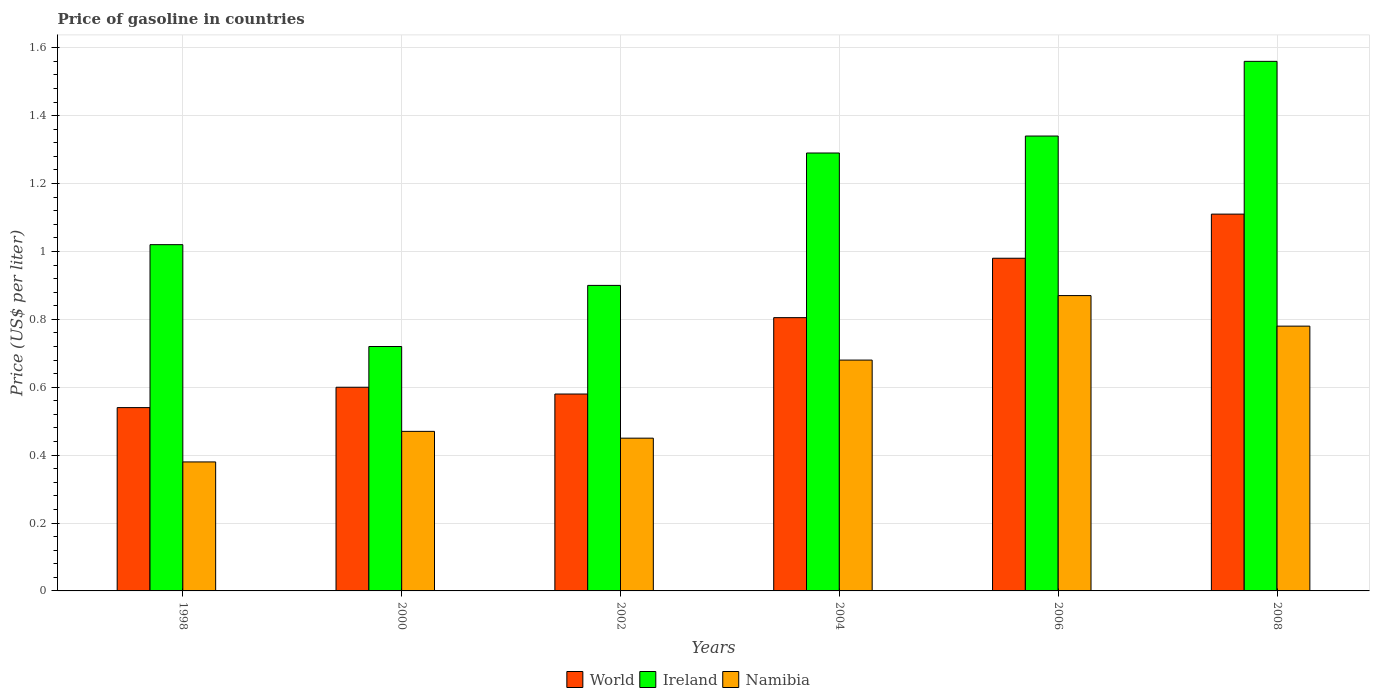Are the number of bars per tick equal to the number of legend labels?
Your answer should be very brief. Yes. How many bars are there on the 4th tick from the left?
Keep it short and to the point. 3. How many bars are there on the 5th tick from the right?
Your answer should be very brief. 3. In how many cases, is the number of bars for a given year not equal to the number of legend labels?
Offer a terse response. 0. What is the price of gasoline in Namibia in 2008?
Provide a short and direct response. 0.78. Across all years, what is the maximum price of gasoline in Ireland?
Make the answer very short. 1.56. Across all years, what is the minimum price of gasoline in Namibia?
Ensure brevity in your answer.  0.38. What is the total price of gasoline in Ireland in the graph?
Give a very brief answer. 6.83. What is the difference between the price of gasoline in Namibia in 1998 and that in 2000?
Keep it short and to the point. -0.09. What is the difference between the price of gasoline in Namibia in 2002 and the price of gasoline in Ireland in 2004?
Offer a terse response. -0.84. What is the average price of gasoline in World per year?
Your answer should be compact. 0.77. In the year 2008, what is the difference between the price of gasoline in Namibia and price of gasoline in Ireland?
Make the answer very short. -0.78. In how many years, is the price of gasoline in Ireland greater than 1.12 US$?
Provide a succinct answer. 3. What is the ratio of the price of gasoline in World in 1998 to that in 2008?
Provide a succinct answer. 0.49. Is the difference between the price of gasoline in Namibia in 2000 and 2002 greater than the difference between the price of gasoline in Ireland in 2000 and 2002?
Your answer should be very brief. Yes. What is the difference between the highest and the second highest price of gasoline in World?
Give a very brief answer. 0.13. What is the difference between the highest and the lowest price of gasoline in Ireland?
Provide a succinct answer. 0.84. What does the 2nd bar from the left in 2004 represents?
Your answer should be compact. Ireland. What does the 1st bar from the right in 2000 represents?
Give a very brief answer. Namibia. How many bars are there?
Provide a short and direct response. 18. Are all the bars in the graph horizontal?
Provide a short and direct response. No. What is the difference between two consecutive major ticks on the Y-axis?
Keep it short and to the point. 0.2. Are the values on the major ticks of Y-axis written in scientific E-notation?
Provide a short and direct response. No. Does the graph contain any zero values?
Your answer should be compact. No. Does the graph contain grids?
Offer a very short reply. Yes. Where does the legend appear in the graph?
Offer a terse response. Bottom center. How are the legend labels stacked?
Your answer should be very brief. Horizontal. What is the title of the graph?
Offer a very short reply. Price of gasoline in countries. What is the label or title of the X-axis?
Your response must be concise. Years. What is the label or title of the Y-axis?
Make the answer very short. Price (US$ per liter). What is the Price (US$ per liter) in World in 1998?
Ensure brevity in your answer.  0.54. What is the Price (US$ per liter) in Namibia in 1998?
Your answer should be very brief. 0.38. What is the Price (US$ per liter) in World in 2000?
Your answer should be compact. 0.6. What is the Price (US$ per liter) in Ireland in 2000?
Offer a terse response. 0.72. What is the Price (US$ per liter) in Namibia in 2000?
Provide a succinct answer. 0.47. What is the Price (US$ per liter) in World in 2002?
Give a very brief answer. 0.58. What is the Price (US$ per liter) in Namibia in 2002?
Keep it short and to the point. 0.45. What is the Price (US$ per liter) in World in 2004?
Your answer should be very brief. 0.81. What is the Price (US$ per liter) of Ireland in 2004?
Keep it short and to the point. 1.29. What is the Price (US$ per liter) of Namibia in 2004?
Offer a terse response. 0.68. What is the Price (US$ per liter) in Ireland in 2006?
Give a very brief answer. 1.34. What is the Price (US$ per liter) in Namibia in 2006?
Your response must be concise. 0.87. What is the Price (US$ per liter) in World in 2008?
Offer a very short reply. 1.11. What is the Price (US$ per liter) of Ireland in 2008?
Your response must be concise. 1.56. What is the Price (US$ per liter) of Namibia in 2008?
Offer a terse response. 0.78. Across all years, what is the maximum Price (US$ per liter) of World?
Give a very brief answer. 1.11. Across all years, what is the maximum Price (US$ per liter) in Ireland?
Your answer should be very brief. 1.56. Across all years, what is the maximum Price (US$ per liter) in Namibia?
Ensure brevity in your answer.  0.87. Across all years, what is the minimum Price (US$ per liter) of World?
Provide a succinct answer. 0.54. Across all years, what is the minimum Price (US$ per liter) of Ireland?
Your answer should be compact. 0.72. Across all years, what is the minimum Price (US$ per liter) in Namibia?
Offer a very short reply. 0.38. What is the total Price (US$ per liter) in World in the graph?
Your response must be concise. 4.62. What is the total Price (US$ per liter) in Ireland in the graph?
Keep it short and to the point. 6.83. What is the total Price (US$ per liter) of Namibia in the graph?
Keep it short and to the point. 3.63. What is the difference between the Price (US$ per liter) of World in 1998 and that in 2000?
Make the answer very short. -0.06. What is the difference between the Price (US$ per liter) in Ireland in 1998 and that in 2000?
Offer a very short reply. 0.3. What is the difference between the Price (US$ per liter) of Namibia in 1998 and that in 2000?
Offer a very short reply. -0.09. What is the difference between the Price (US$ per liter) of World in 1998 and that in 2002?
Your answer should be very brief. -0.04. What is the difference between the Price (US$ per liter) of Ireland in 1998 and that in 2002?
Make the answer very short. 0.12. What is the difference between the Price (US$ per liter) of Namibia in 1998 and that in 2002?
Your answer should be very brief. -0.07. What is the difference between the Price (US$ per liter) in World in 1998 and that in 2004?
Your answer should be compact. -0.27. What is the difference between the Price (US$ per liter) in Ireland in 1998 and that in 2004?
Your answer should be compact. -0.27. What is the difference between the Price (US$ per liter) of Namibia in 1998 and that in 2004?
Offer a very short reply. -0.3. What is the difference between the Price (US$ per liter) in World in 1998 and that in 2006?
Give a very brief answer. -0.44. What is the difference between the Price (US$ per liter) of Ireland in 1998 and that in 2006?
Offer a terse response. -0.32. What is the difference between the Price (US$ per liter) in Namibia in 1998 and that in 2006?
Offer a very short reply. -0.49. What is the difference between the Price (US$ per liter) in World in 1998 and that in 2008?
Provide a short and direct response. -0.57. What is the difference between the Price (US$ per liter) of Ireland in 1998 and that in 2008?
Your answer should be very brief. -0.54. What is the difference between the Price (US$ per liter) of Namibia in 1998 and that in 2008?
Provide a succinct answer. -0.4. What is the difference between the Price (US$ per liter) of World in 2000 and that in 2002?
Keep it short and to the point. 0.02. What is the difference between the Price (US$ per liter) of Ireland in 2000 and that in 2002?
Give a very brief answer. -0.18. What is the difference between the Price (US$ per liter) in World in 2000 and that in 2004?
Keep it short and to the point. -0.2. What is the difference between the Price (US$ per liter) in Ireland in 2000 and that in 2004?
Your response must be concise. -0.57. What is the difference between the Price (US$ per liter) of Namibia in 2000 and that in 2004?
Give a very brief answer. -0.21. What is the difference between the Price (US$ per liter) of World in 2000 and that in 2006?
Ensure brevity in your answer.  -0.38. What is the difference between the Price (US$ per liter) in Ireland in 2000 and that in 2006?
Provide a short and direct response. -0.62. What is the difference between the Price (US$ per liter) of Namibia in 2000 and that in 2006?
Offer a very short reply. -0.4. What is the difference between the Price (US$ per liter) in World in 2000 and that in 2008?
Ensure brevity in your answer.  -0.51. What is the difference between the Price (US$ per liter) of Ireland in 2000 and that in 2008?
Your response must be concise. -0.84. What is the difference between the Price (US$ per liter) of Namibia in 2000 and that in 2008?
Provide a succinct answer. -0.31. What is the difference between the Price (US$ per liter) in World in 2002 and that in 2004?
Make the answer very short. -0.23. What is the difference between the Price (US$ per liter) in Ireland in 2002 and that in 2004?
Give a very brief answer. -0.39. What is the difference between the Price (US$ per liter) in Namibia in 2002 and that in 2004?
Your answer should be compact. -0.23. What is the difference between the Price (US$ per liter) in Ireland in 2002 and that in 2006?
Offer a terse response. -0.44. What is the difference between the Price (US$ per liter) in Namibia in 2002 and that in 2006?
Your answer should be compact. -0.42. What is the difference between the Price (US$ per liter) of World in 2002 and that in 2008?
Make the answer very short. -0.53. What is the difference between the Price (US$ per liter) in Ireland in 2002 and that in 2008?
Make the answer very short. -0.66. What is the difference between the Price (US$ per liter) in Namibia in 2002 and that in 2008?
Provide a succinct answer. -0.33. What is the difference between the Price (US$ per liter) in World in 2004 and that in 2006?
Provide a succinct answer. -0.17. What is the difference between the Price (US$ per liter) of Namibia in 2004 and that in 2006?
Offer a terse response. -0.19. What is the difference between the Price (US$ per liter) of World in 2004 and that in 2008?
Offer a terse response. -0.3. What is the difference between the Price (US$ per liter) in Ireland in 2004 and that in 2008?
Offer a very short reply. -0.27. What is the difference between the Price (US$ per liter) of World in 2006 and that in 2008?
Your answer should be compact. -0.13. What is the difference between the Price (US$ per liter) in Ireland in 2006 and that in 2008?
Offer a very short reply. -0.22. What is the difference between the Price (US$ per liter) of Namibia in 2006 and that in 2008?
Give a very brief answer. 0.09. What is the difference between the Price (US$ per liter) of World in 1998 and the Price (US$ per liter) of Ireland in 2000?
Give a very brief answer. -0.18. What is the difference between the Price (US$ per liter) of World in 1998 and the Price (US$ per liter) of Namibia in 2000?
Keep it short and to the point. 0.07. What is the difference between the Price (US$ per liter) of Ireland in 1998 and the Price (US$ per liter) of Namibia in 2000?
Ensure brevity in your answer.  0.55. What is the difference between the Price (US$ per liter) of World in 1998 and the Price (US$ per liter) of Ireland in 2002?
Ensure brevity in your answer.  -0.36. What is the difference between the Price (US$ per liter) in World in 1998 and the Price (US$ per liter) in Namibia in 2002?
Provide a succinct answer. 0.09. What is the difference between the Price (US$ per liter) in Ireland in 1998 and the Price (US$ per liter) in Namibia in 2002?
Your response must be concise. 0.57. What is the difference between the Price (US$ per liter) in World in 1998 and the Price (US$ per liter) in Ireland in 2004?
Keep it short and to the point. -0.75. What is the difference between the Price (US$ per liter) of World in 1998 and the Price (US$ per liter) of Namibia in 2004?
Ensure brevity in your answer.  -0.14. What is the difference between the Price (US$ per liter) of Ireland in 1998 and the Price (US$ per liter) of Namibia in 2004?
Your answer should be compact. 0.34. What is the difference between the Price (US$ per liter) in World in 1998 and the Price (US$ per liter) in Namibia in 2006?
Provide a succinct answer. -0.33. What is the difference between the Price (US$ per liter) in Ireland in 1998 and the Price (US$ per liter) in Namibia in 2006?
Your response must be concise. 0.15. What is the difference between the Price (US$ per liter) in World in 1998 and the Price (US$ per liter) in Ireland in 2008?
Make the answer very short. -1.02. What is the difference between the Price (US$ per liter) in World in 1998 and the Price (US$ per liter) in Namibia in 2008?
Keep it short and to the point. -0.24. What is the difference between the Price (US$ per liter) of Ireland in 1998 and the Price (US$ per liter) of Namibia in 2008?
Offer a terse response. 0.24. What is the difference between the Price (US$ per liter) of Ireland in 2000 and the Price (US$ per liter) of Namibia in 2002?
Give a very brief answer. 0.27. What is the difference between the Price (US$ per liter) of World in 2000 and the Price (US$ per liter) of Ireland in 2004?
Your answer should be very brief. -0.69. What is the difference between the Price (US$ per liter) of World in 2000 and the Price (US$ per liter) of Namibia in 2004?
Your answer should be compact. -0.08. What is the difference between the Price (US$ per liter) in Ireland in 2000 and the Price (US$ per liter) in Namibia in 2004?
Provide a short and direct response. 0.04. What is the difference between the Price (US$ per liter) in World in 2000 and the Price (US$ per liter) in Ireland in 2006?
Your answer should be very brief. -0.74. What is the difference between the Price (US$ per liter) of World in 2000 and the Price (US$ per liter) of Namibia in 2006?
Your answer should be very brief. -0.27. What is the difference between the Price (US$ per liter) of World in 2000 and the Price (US$ per liter) of Ireland in 2008?
Ensure brevity in your answer.  -0.96. What is the difference between the Price (US$ per liter) of World in 2000 and the Price (US$ per liter) of Namibia in 2008?
Ensure brevity in your answer.  -0.18. What is the difference between the Price (US$ per liter) of Ireland in 2000 and the Price (US$ per liter) of Namibia in 2008?
Ensure brevity in your answer.  -0.06. What is the difference between the Price (US$ per liter) in World in 2002 and the Price (US$ per liter) in Ireland in 2004?
Offer a terse response. -0.71. What is the difference between the Price (US$ per liter) of Ireland in 2002 and the Price (US$ per liter) of Namibia in 2004?
Offer a very short reply. 0.22. What is the difference between the Price (US$ per liter) of World in 2002 and the Price (US$ per liter) of Ireland in 2006?
Give a very brief answer. -0.76. What is the difference between the Price (US$ per liter) of World in 2002 and the Price (US$ per liter) of Namibia in 2006?
Provide a short and direct response. -0.29. What is the difference between the Price (US$ per liter) of Ireland in 2002 and the Price (US$ per liter) of Namibia in 2006?
Your answer should be compact. 0.03. What is the difference between the Price (US$ per liter) in World in 2002 and the Price (US$ per liter) in Ireland in 2008?
Your answer should be compact. -0.98. What is the difference between the Price (US$ per liter) of World in 2002 and the Price (US$ per liter) of Namibia in 2008?
Provide a succinct answer. -0.2. What is the difference between the Price (US$ per liter) in Ireland in 2002 and the Price (US$ per liter) in Namibia in 2008?
Make the answer very short. 0.12. What is the difference between the Price (US$ per liter) of World in 2004 and the Price (US$ per liter) of Ireland in 2006?
Provide a short and direct response. -0.54. What is the difference between the Price (US$ per liter) of World in 2004 and the Price (US$ per liter) of Namibia in 2006?
Offer a very short reply. -0.07. What is the difference between the Price (US$ per liter) of Ireland in 2004 and the Price (US$ per liter) of Namibia in 2006?
Your answer should be very brief. 0.42. What is the difference between the Price (US$ per liter) in World in 2004 and the Price (US$ per liter) in Ireland in 2008?
Keep it short and to the point. -0.76. What is the difference between the Price (US$ per liter) in World in 2004 and the Price (US$ per liter) in Namibia in 2008?
Your response must be concise. 0.03. What is the difference between the Price (US$ per liter) of Ireland in 2004 and the Price (US$ per liter) of Namibia in 2008?
Your answer should be compact. 0.51. What is the difference between the Price (US$ per liter) of World in 2006 and the Price (US$ per liter) of Ireland in 2008?
Your response must be concise. -0.58. What is the difference between the Price (US$ per liter) in World in 2006 and the Price (US$ per liter) in Namibia in 2008?
Give a very brief answer. 0.2. What is the difference between the Price (US$ per liter) in Ireland in 2006 and the Price (US$ per liter) in Namibia in 2008?
Give a very brief answer. 0.56. What is the average Price (US$ per liter) of World per year?
Provide a succinct answer. 0.77. What is the average Price (US$ per liter) in Ireland per year?
Give a very brief answer. 1.14. What is the average Price (US$ per liter) of Namibia per year?
Offer a very short reply. 0.6. In the year 1998, what is the difference between the Price (US$ per liter) in World and Price (US$ per liter) in Ireland?
Make the answer very short. -0.48. In the year 1998, what is the difference between the Price (US$ per liter) in World and Price (US$ per liter) in Namibia?
Your response must be concise. 0.16. In the year 1998, what is the difference between the Price (US$ per liter) in Ireland and Price (US$ per liter) in Namibia?
Ensure brevity in your answer.  0.64. In the year 2000, what is the difference between the Price (US$ per liter) in World and Price (US$ per liter) in Ireland?
Keep it short and to the point. -0.12. In the year 2000, what is the difference between the Price (US$ per liter) in World and Price (US$ per liter) in Namibia?
Give a very brief answer. 0.13. In the year 2000, what is the difference between the Price (US$ per liter) of Ireland and Price (US$ per liter) of Namibia?
Give a very brief answer. 0.25. In the year 2002, what is the difference between the Price (US$ per liter) of World and Price (US$ per liter) of Ireland?
Ensure brevity in your answer.  -0.32. In the year 2002, what is the difference between the Price (US$ per liter) of World and Price (US$ per liter) of Namibia?
Make the answer very short. 0.13. In the year 2002, what is the difference between the Price (US$ per liter) of Ireland and Price (US$ per liter) of Namibia?
Ensure brevity in your answer.  0.45. In the year 2004, what is the difference between the Price (US$ per liter) of World and Price (US$ per liter) of Ireland?
Provide a succinct answer. -0.48. In the year 2004, what is the difference between the Price (US$ per liter) of World and Price (US$ per liter) of Namibia?
Make the answer very short. 0.12. In the year 2004, what is the difference between the Price (US$ per liter) of Ireland and Price (US$ per liter) of Namibia?
Your answer should be very brief. 0.61. In the year 2006, what is the difference between the Price (US$ per liter) in World and Price (US$ per liter) in Ireland?
Keep it short and to the point. -0.36. In the year 2006, what is the difference between the Price (US$ per liter) in World and Price (US$ per liter) in Namibia?
Offer a terse response. 0.11. In the year 2006, what is the difference between the Price (US$ per liter) of Ireland and Price (US$ per liter) of Namibia?
Your answer should be compact. 0.47. In the year 2008, what is the difference between the Price (US$ per liter) in World and Price (US$ per liter) in Ireland?
Provide a succinct answer. -0.45. In the year 2008, what is the difference between the Price (US$ per liter) of World and Price (US$ per liter) of Namibia?
Keep it short and to the point. 0.33. In the year 2008, what is the difference between the Price (US$ per liter) in Ireland and Price (US$ per liter) in Namibia?
Your answer should be compact. 0.78. What is the ratio of the Price (US$ per liter) in Ireland in 1998 to that in 2000?
Ensure brevity in your answer.  1.42. What is the ratio of the Price (US$ per liter) of Namibia in 1998 to that in 2000?
Ensure brevity in your answer.  0.81. What is the ratio of the Price (US$ per liter) of World in 1998 to that in 2002?
Offer a terse response. 0.93. What is the ratio of the Price (US$ per liter) of Ireland in 1998 to that in 2002?
Ensure brevity in your answer.  1.13. What is the ratio of the Price (US$ per liter) in Namibia in 1998 to that in 2002?
Your answer should be very brief. 0.84. What is the ratio of the Price (US$ per liter) of World in 1998 to that in 2004?
Ensure brevity in your answer.  0.67. What is the ratio of the Price (US$ per liter) in Ireland in 1998 to that in 2004?
Offer a very short reply. 0.79. What is the ratio of the Price (US$ per liter) in Namibia in 1998 to that in 2004?
Give a very brief answer. 0.56. What is the ratio of the Price (US$ per liter) of World in 1998 to that in 2006?
Provide a succinct answer. 0.55. What is the ratio of the Price (US$ per liter) of Ireland in 1998 to that in 2006?
Give a very brief answer. 0.76. What is the ratio of the Price (US$ per liter) of Namibia in 1998 to that in 2006?
Make the answer very short. 0.44. What is the ratio of the Price (US$ per liter) in World in 1998 to that in 2008?
Ensure brevity in your answer.  0.49. What is the ratio of the Price (US$ per liter) of Ireland in 1998 to that in 2008?
Your answer should be very brief. 0.65. What is the ratio of the Price (US$ per liter) of Namibia in 1998 to that in 2008?
Ensure brevity in your answer.  0.49. What is the ratio of the Price (US$ per liter) in World in 2000 to that in 2002?
Make the answer very short. 1.03. What is the ratio of the Price (US$ per liter) of Ireland in 2000 to that in 2002?
Offer a very short reply. 0.8. What is the ratio of the Price (US$ per liter) of Namibia in 2000 to that in 2002?
Offer a very short reply. 1.04. What is the ratio of the Price (US$ per liter) of World in 2000 to that in 2004?
Give a very brief answer. 0.75. What is the ratio of the Price (US$ per liter) in Ireland in 2000 to that in 2004?
Provide a succinct answer. 0.56. What is the ratio of the Price (US$ per liter) of Namibia in 2000 to that in 2004?
Provide a succinct answer. 0.69. What is the ratio of the Price (US$ per liter) in World in 2000 to that in 2006?
Give a very brief answer. 0.61. What is the ratio of the Price (US$ per liter) of Ireland in 2000 to that in 2006?
Make the answer very short. 0.54. What is the ratio of the Price (US$ per liter) in Namibia in 2000 to that in 2006?
Make the answer very short. 0.54. What is the ratio of the Price (US$ per liter) in World in 2000 to that in 2008?
Offer a very short reply. 0.54. What is the ratio of the Price (US$ per liter) in Ireland in 2000 to that in 2008?
Give a very brief answer. 0.46. What is the ratio of the Price (US$ per liter) in Namibia in 2000 to that in 2008?
Offer a very short reply. 0.6. What is the ratio of the Price (US$ per liter) in World in 2002 to that in 2004?
Keep it short and to the point. 0.72. What is the ratio of the Price (US$ per liter) in Ireland in 2002 to that in 2004?
Give a very brief answer. 0.7. What is the ratio of the Price (US$ per liter) in Namibia in 2002 to that in 2004?
Make the answer very short. 0.66. What is the ratio of the Price (US$ per liter) in World in 2002 to that in 2006?
Provide a succinct answer. 0.59. What is the ratio of the Price (US$ per liter) of Ireland in 2002 to that in 2006?
Make the answer very short. 0.67. What is the ratio of the Price (US$ per liter) of Namibia in 2002 to that in 2006?
Make the answer very short. 0.52. What is the ratio of the Price (US$ per liter) in World in 2002 to that in 2008?
Give a very brief answer. 0.52. What is the ratio of the Price (US$ per liter) in Ireland in 2002 to that in 2008?
Ensure brevity in your answer.  0.58. What is the ratio of the Price (US$ per liter) of Namibia in 2002 to that in 2008?
Your response must be concise. 0.58. What is the ratio of the Price (US$ per liter) of World in 2004 to that in 2006?
Keep it short and to the point. 0.82. What is the ratio of the Price (US$ per liter) of Ireland in 2004 to that in 2006?
Offer a very short reply. 0.96. What is the ratio of the Price (US$ per liter) of Namibia in 2004 to that in 2006?
Make the answer very short. 0.78. What is the ratio of the Price (US$ per liter) of World in 2004 to that in 2008?
Your response must be concise. 0.73. What is the ratio of the Price (US$ per liter) in Ireland in 2004 to that in 2008?
Keep it short and to the point. 0.83. What is the ratio of the Price (US$ per liter) of Namibia in 2004 to that in 2008?
Your answer should be very brief. 0.87. What is the ratio of the Price (US$ per liter) of World in 2006 to that in 2008?
Make the answer very short. 0.88. What is the ratio of the Price (US$ per liter) of Ireland in 2006 to that in 2008?
Offer a terse response. 0.86. What is the ratio of the Price (US$ per liter) in Namibia in 2006 to that in 2008?
Give a very brief answer. 1.12. What is the difference between the highest and the second highest Price (US$ per liter) of World?
Offer a very short reply. 0.13. What is the difference between the highest and the second highest Price (US$ per liter) of Ireland?
Your response must be concise. 0.22. What is the difference between the highest and the second highest Price (US$ per liter) in Namibia?
Give a very brief answer. 0.09. What is the difference between the highest and the lowest Price (US$ per liter) of World?
Make the answer very short. 0.57. What is the difference between the highest and the lowest Price (US$ per liter) in Ireland?
Give a very brief answer. 0.84. What is the difference between the highest and the lowest Price (US$ per liter) of Namibia?
Your answer should be very brief. 0.49. 